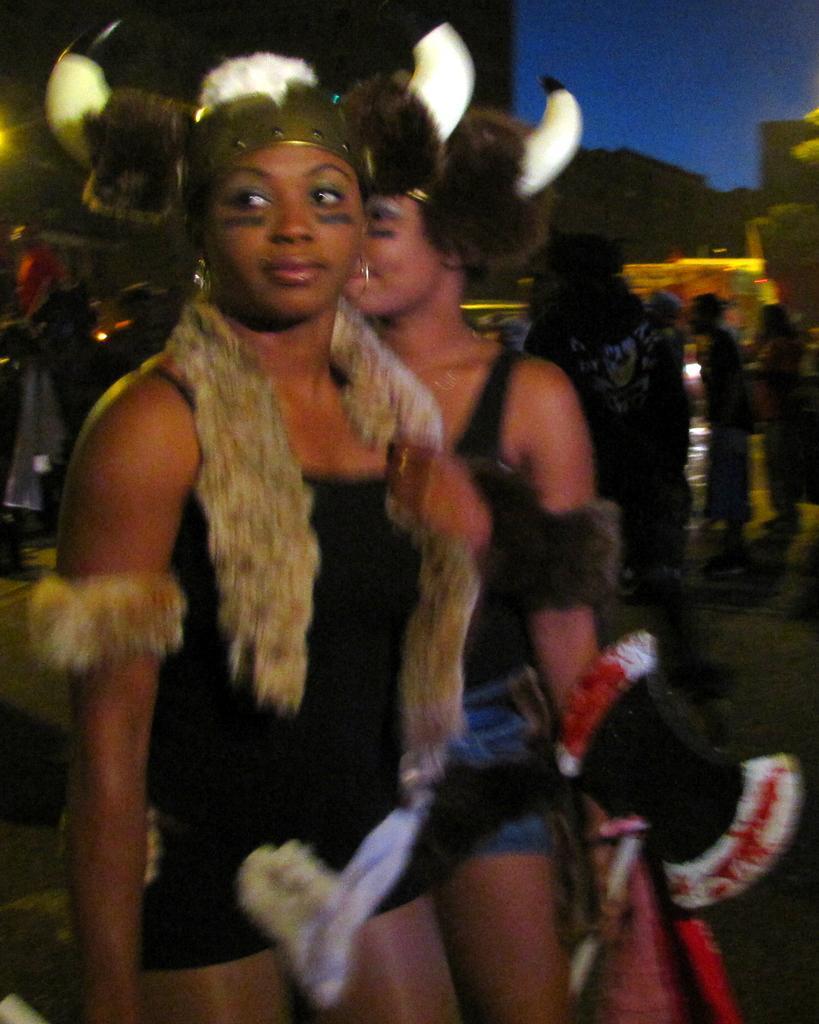Can you describe this image briefly? In this image, we can see a group of people. Few are wearing different costumes. Background we can see wall and sky. 